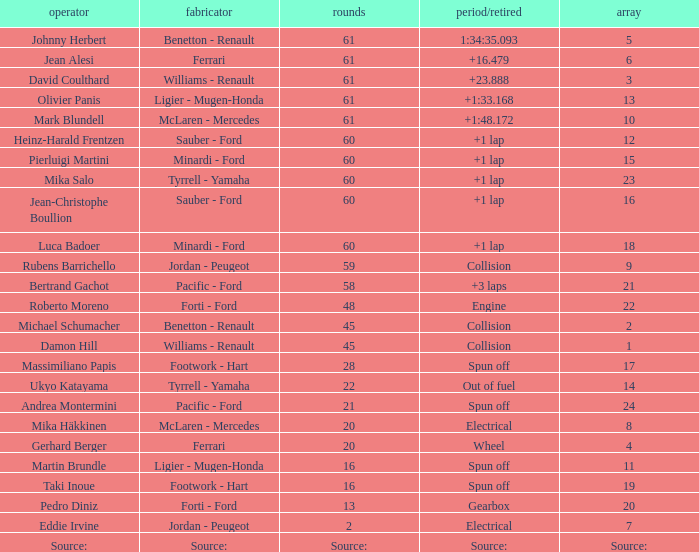How many laps does roberto moreno have? 48.0. Could you parse the entire table as a dict? {'header': ['operator', 'fabricator', 'rounds', 'period/retired', 'array'], 'rows': [['Johnny Herbert', 'Benetton - Renault', '61', '1:34:35.093', '5'], ['Jean Alesi', 'Ferrari', '61', '+16.479', '6'], ['David Coulthard', 'Williams - Renault', '61', '+23.888', '3'], ['Olivier Panis', 'Ligier - Mugen-Honda', '61', '+1:33.168', '13'], ['Mark Blundell', 'McLaren - Mercedes', '61', '+1:48.172', '10'], ['Heinz-Harald Frentzen', 'Sauber - Ford', '60', '+1 lap', '12'], ['Pierluigi Martini', 'Minardi - Ford', '60', '+1 lap', '15'], ['Mika Salo', 'Tyrrell - Yamaha', '60', '+1 lap', '23'], ['Jean-Christophe Boullion', 'Sauber - Ford', '60', '+1 lap', '16'], ['Luca Badoer', 'Minardi - Ford', '60', '+1 lap', '18'], ['Rubens Barrichello', 'Jordan - Peugeot', '59', 'Collision', '9'], ['Bertrand Gachot', 'Pacific - Ford', '58', '+3 laps', '21'], ['Roberto Moreno', 'Forti - Ford', '48', 'Engine', '22'], ['Michael Schumacher', 'Benetton - Renault', '45', 'Collision', '2'], ['Damon Hill', 'Williams - Renault', '45', 'Collision', '1'], ['Massimiliano Papis', 'Footwork - Hart', '28', 'Spun off', '17'], ['Ukyo Katayama', 'Tyrrell - Yamaha', '22', 'Out of fuel', '14'], ['Andrea Montermini', 'Pacific - Ford', '21', 'Spun off', '24'], ['Mika Häkkinen', 'McLaren - Mercedes', '20', 'Electrical', '8'], ['Gerhard Berger', 'Ferrari', '20', 'Wheel', '4'], ['Martin Brundle', 'Ligier - Mugen-Honda', '16', 'Spun off', '11'], ['Taki Inoue', 'Footwork - Hart', '16', 'Spun off', '19'], ['Pedro Diniz', 'Forti - Ford', '13', 'Gearbox', '20'], ['Eddie Irvine', 'Jordan - Peugeot', '2', 'Electrical', '7'], ['Source:', 'Source:', 'Source:', 'Source:', 'Source:']]} 